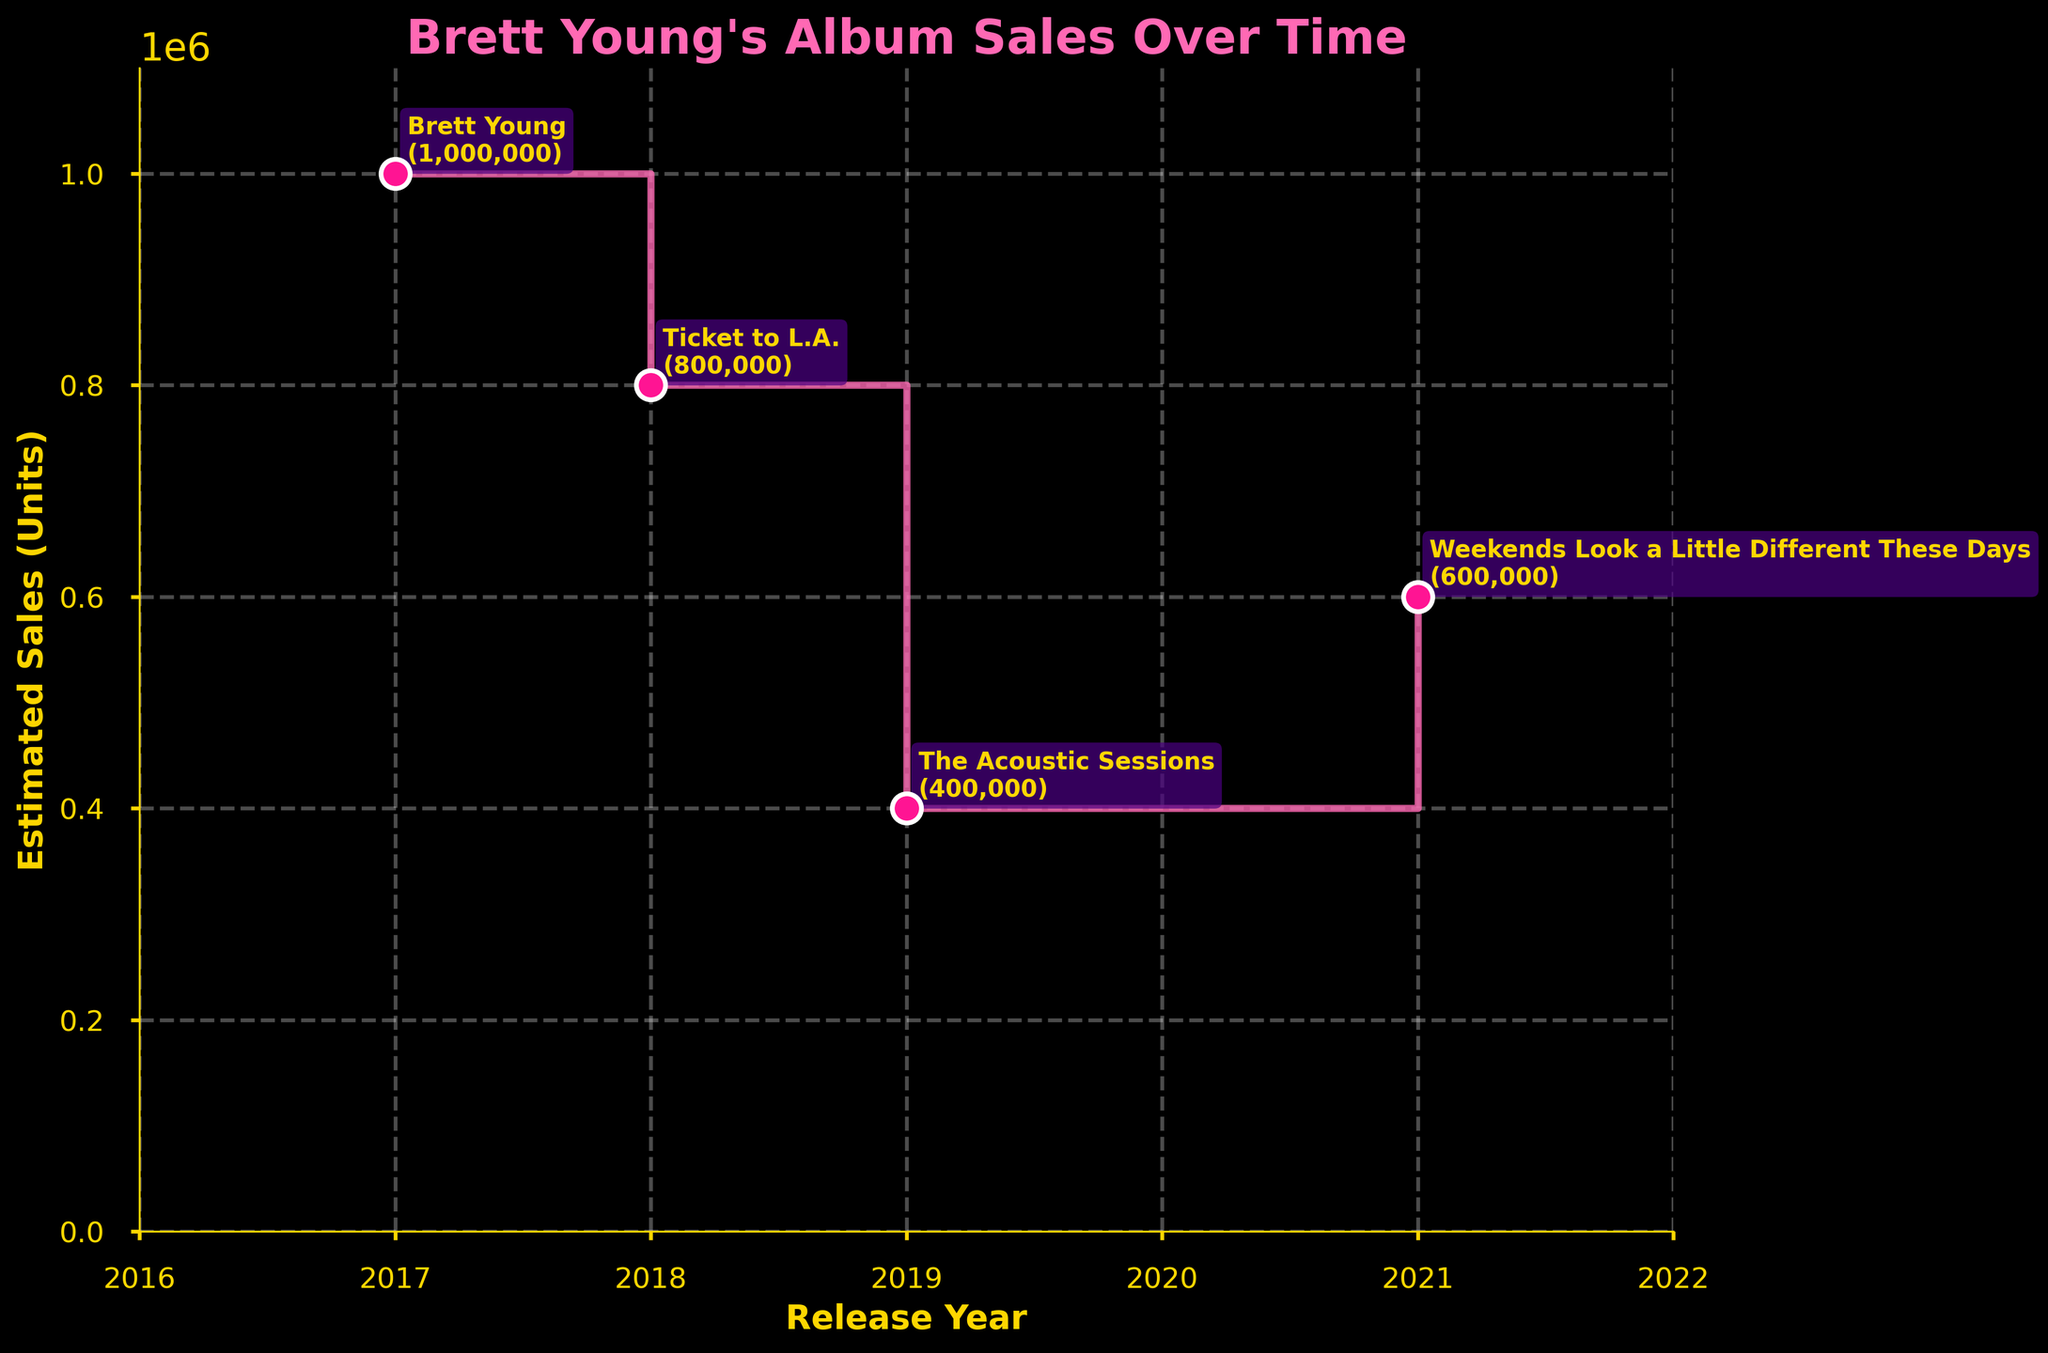What is the title of the figure? The title is displayed at the top of the figure in larger, bold pink text.
Answer: Brett Young's Album Sales Over Time How many albums are shown in the plot? Count the number of annotations (album names) placed along the data points in the plot.
Answer: 4 Which album had the highest estimated sales? Identify the highest point on the y-axis and look at the annotation next to this point.
Answer: Brett Young Which album was released in 2019? Look at the x-axis labels for the year 2019 and check the annotation of the data point above it.
Answer: The Acoustic Sessions What is the estimated sales figure for 'Ticket to L.A.'? Find the annotation for 'Ticket to L.A.' and read the sales figure next to it.
Answer: 800,000 How many years after 'The Acoustic Sessions' was 'Weekends Look a Little Different These Days' released? Subtract the release year of 'The Acoustic Sessions' from the release year of 'Weekends Look a Little Different These Days' (2021 - 2019).
Answer: 2 Which album had the second highest estimated sales? Identify the second highest point on the y-axis and look at the annotation next to this point.
Answer: Ticket to L.A In which year did the sales drop the most compared to the previous album? Compare the drop between consecutive albums by looking at the difference in y-axis values; the largest drop is between 'Ticket to L.A.' and 'The Acoustic Sessions'.
Answer: 2019 What is the average estimated sales of Brett Young's albums? Sum the sales figures of all albums (1,000,000 + 800,000 + 400,000 + 600,000) and divide by the number of albums (4).
Answer: 700,000 By how much did the sales of 'Weekends Look a Little Different These Days' exceed 'The Acoustic Sessions'? Subtract the sales figure of 'The Acoustic Sessions' from that of 'Weekends Look a Little Different These Days' (600,000 - 400,000).
Answer: 200,000 